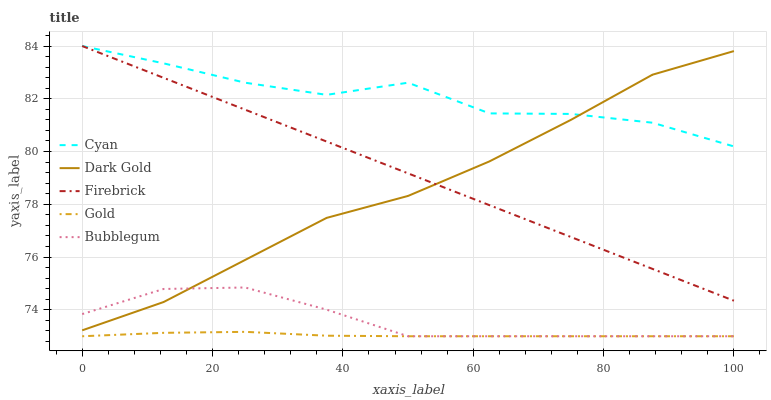Does Gold have the minimum area under the curve?
Answer yes or no. Yes. Does Cyan have the maximum area under the curve?
Answer yes or no. Yes. Does Firebrick have the minimum area under the curve?
Answer yes or no. No. Does Firebrick have the maximum area under the curve?
Answer yes or no. No. Is Firebrick the smoothest?
Answer yes or no. Yes. Is Cyan the roughest?
Answer yes or no. Yes. Is Bubblegum the smoothest?
Answer yes or no. No. Is Bubblegum the roughest?
Answer yes or no. No. Does Bubblegum have the lowest value?
Answer yes or no. Yes. Does Firebrick have the lowest value?
Answer yes or no. No. Does Firebrick have the highest value?
Answer yes or no. Yes. Does Bubblegum have the highest value?
Answer yes or no. No. Is Bubblegum less than Firebrick?
Answer yes or no. Yes. Is Firebrick greater than Bubblegum?
Answer yes or no. Yes. Does Dark Gold intersect Firebrick?
Answer yes or no. Yes. Is Dark Gold less than Firebrick?
Answer yes or no. No. Is Dark Gold greater than Firebrick?
Answer yes or no. No. Does Bubblegum intersect Firebrick?
Answer yes or no. No. 